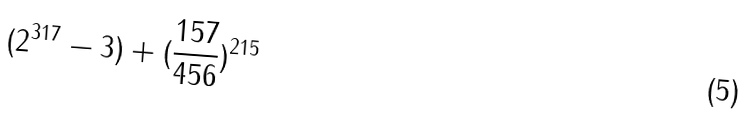Convert formula to latex. <formula><loc_0><loc_0><loc_500><loc_500>( 2 ^ { 3 1 7 } - 3 ) + ( \frac { 1 5 7 } { 4 5 6 } ) ^ { 2 1 5 }</formula> 